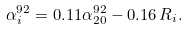Convert formula to latex. <formula><loc_0><loc_0><loc_500><loc_500>\alpha ^ { 9 2 } _ { i } = 0 . 1 1 \alpha _ { 2 0 } ^ { 9 2 } - 0 . 1 6 \, R _ { i } .</formula> 